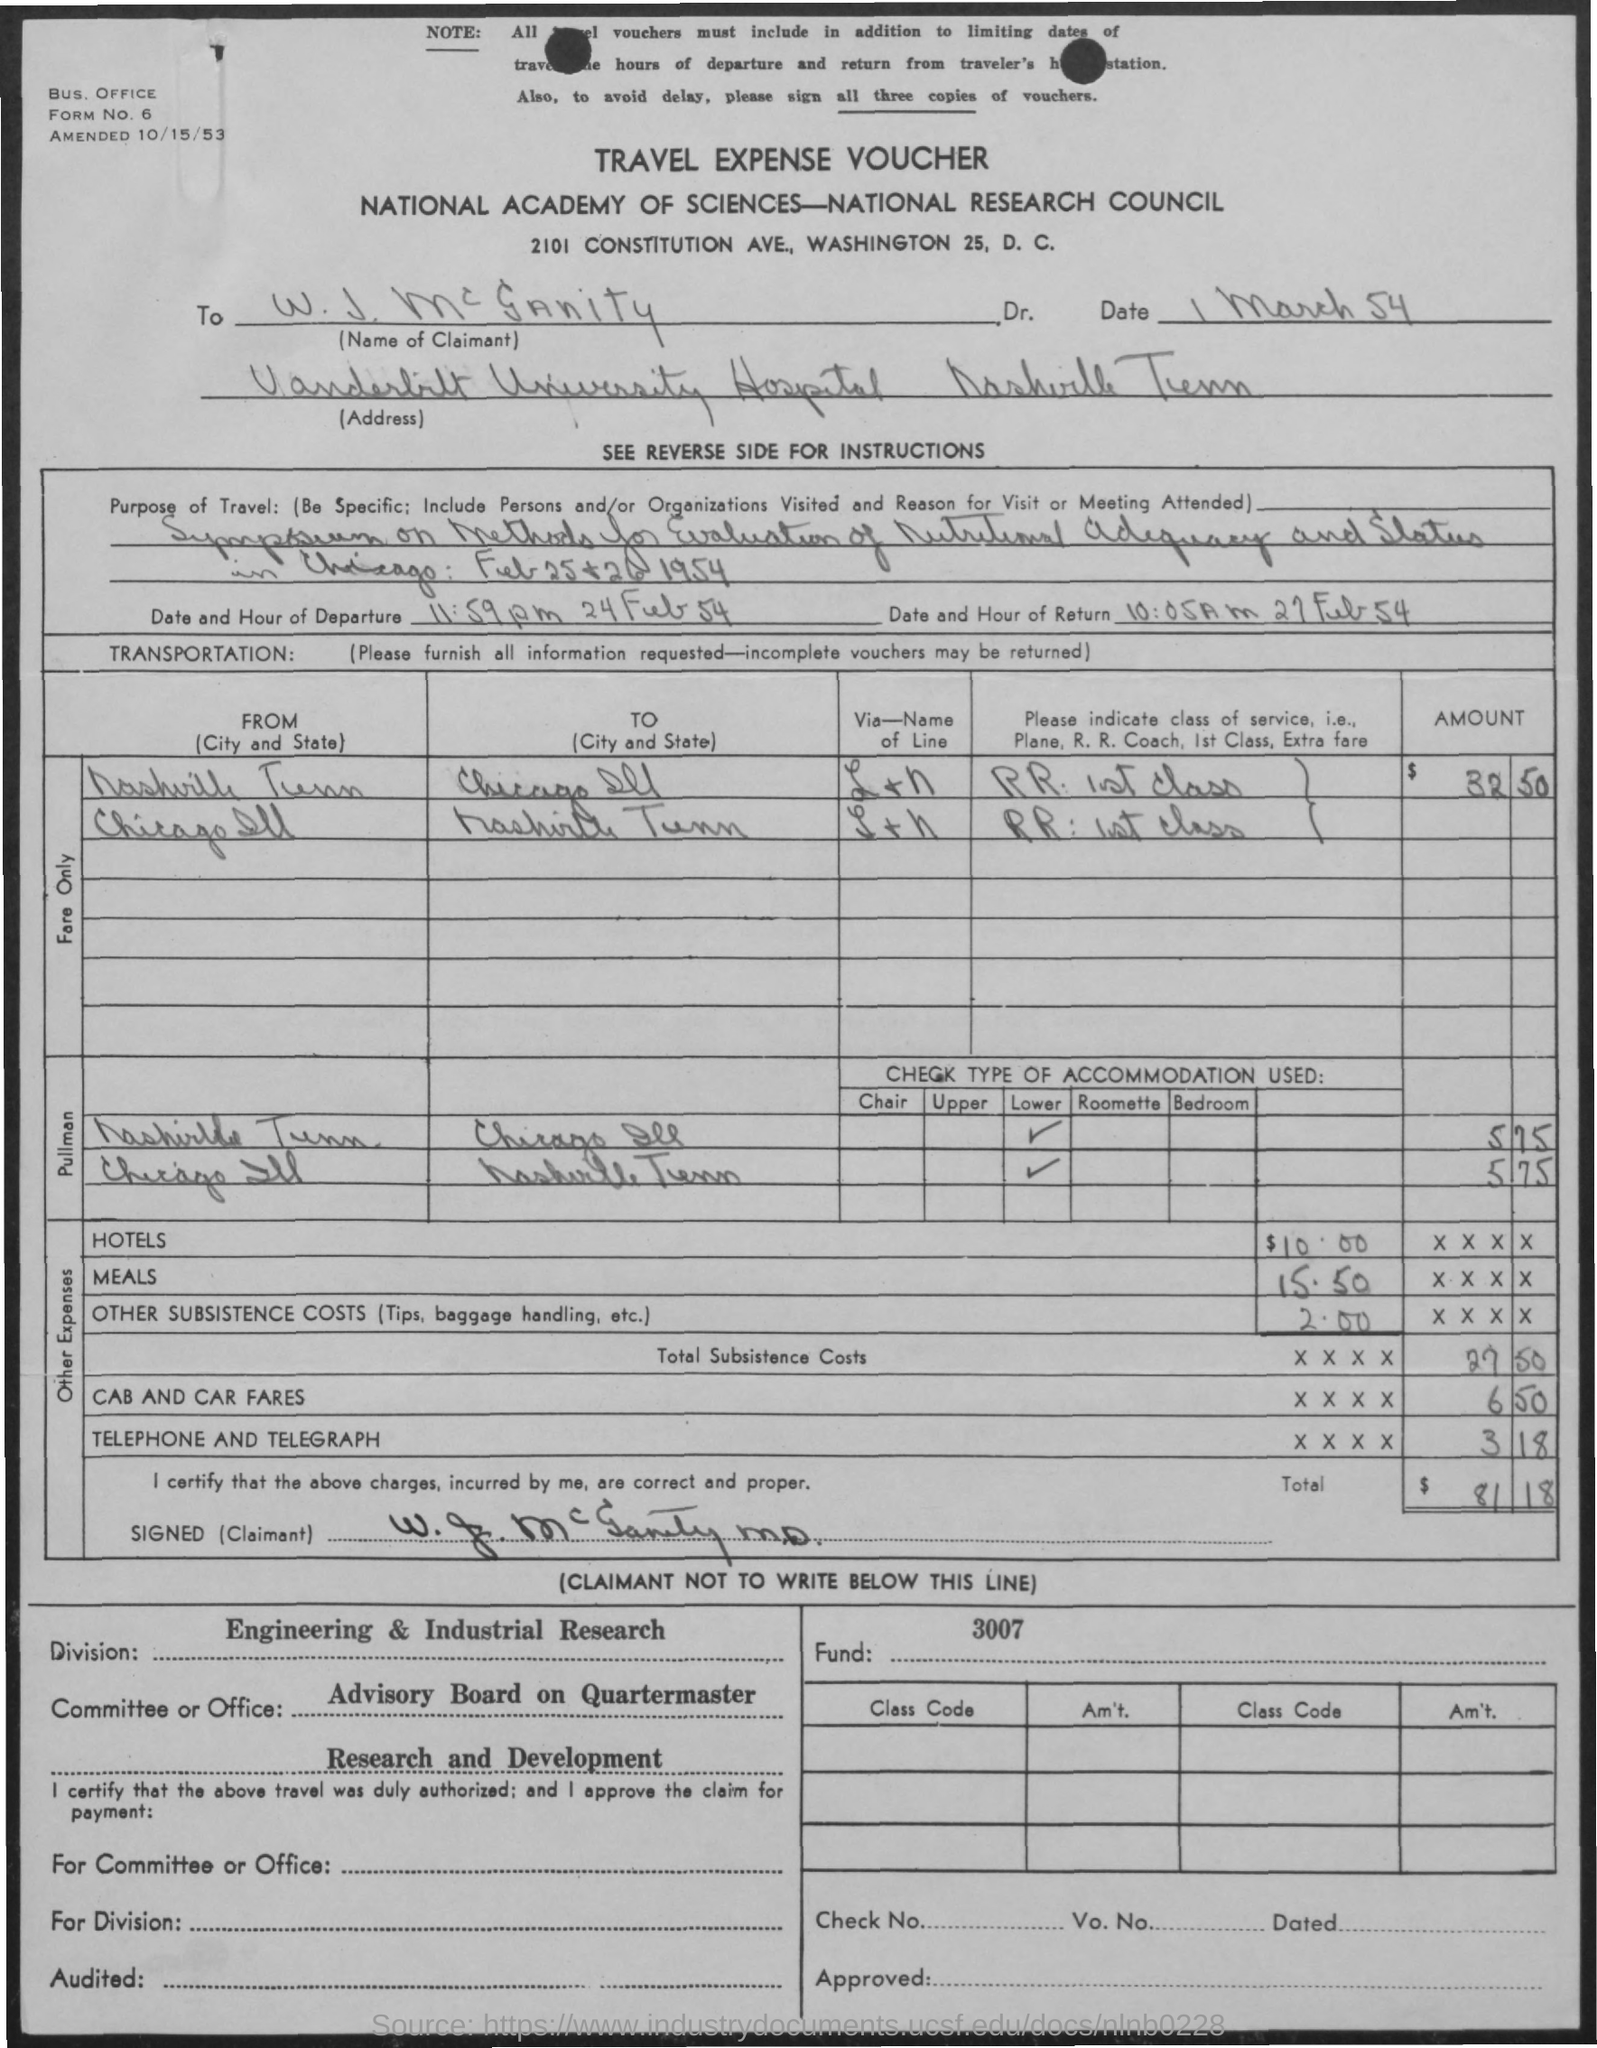Are there any notable annotations or remarks on the voucher? Yes, there is a notable annotation on the voucher that states 'Engineering & Industrial Research' in the division section, which highlights the likely research or industrial-related nature of Dr. McCrannity's work. Additionally, it was approved by the Advisory Board on Quartermaster on Research and Development, which points to its connection with military logistics and development. 